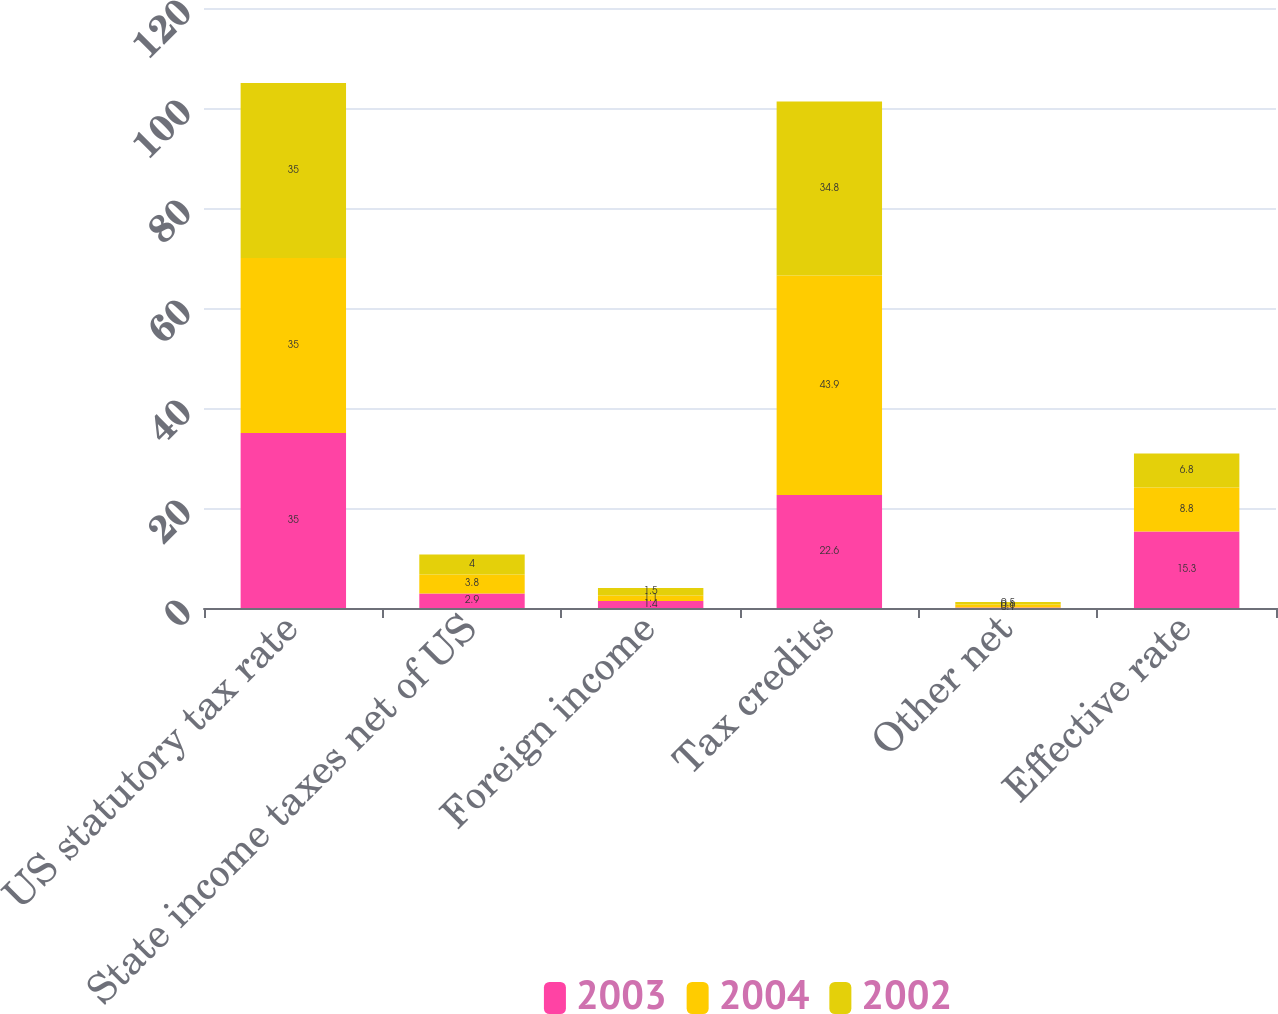Convert chart to OTSL. <chart><loc_0><loc_0><loc_500><loc_500><stacked_bar_chart><ecel><fcel>US statutory tax rate<fcel>State income taxes net of US<fcel>Foreign income<fcel>Tax credits<fcel>Other net<fcel>Effective rate<nl><fcel>2003<fcel>35<fcel>2.9<fcel>1.4<fcel>22.6<fcel>0.1<fcel>15.3<nl><fcel>2004<fcel>35<fcel>3.8<fcel>1.1<fcel>43.9<fcel>0.6<fcel>8.8<nl><fcel>2002<fcel>35<fcel>4<fcel>1.5<fcel>34.8<fcel>0.5<fcel>6.8<nl></chart> 